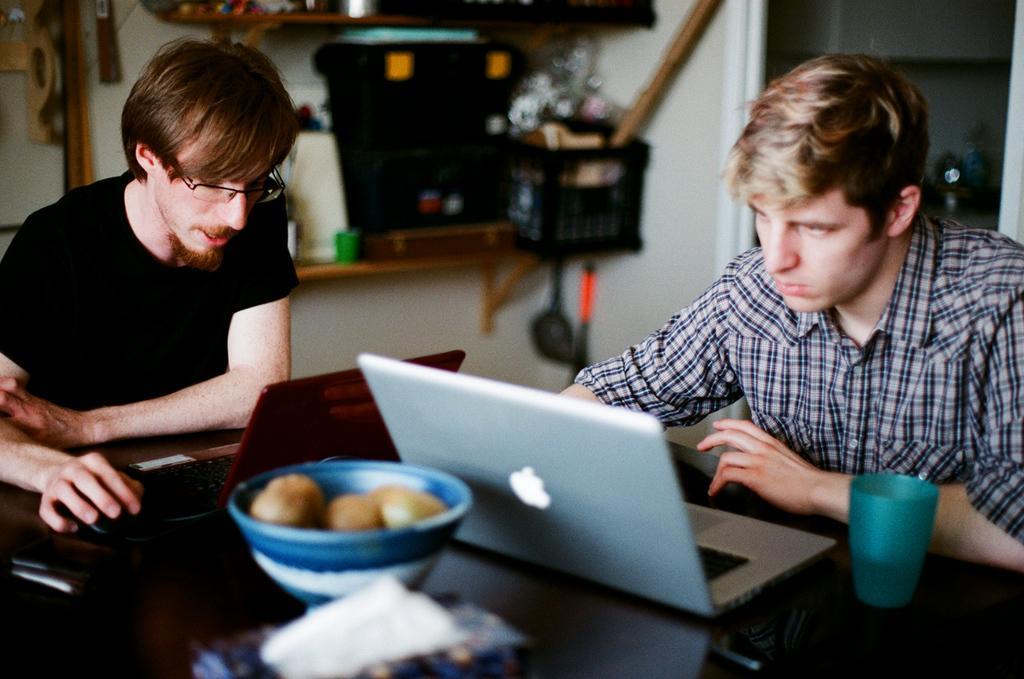Could you give a brief overview of what you see in this image? In the picture we can see a table near to it, we can see two men are sitting on the chairs and working on the laptop and one man is observing it and behind the laptop we can see a bowl with some fruits and beside the laptop we can see a glass which is blue in color and in the background we can see a rack with some things on it. 